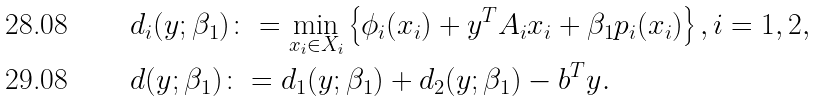Convert formula to latex. <formula><loc_0><loc_0><loc_500><loc_500>& d _ { i } ( y ; \beta _ { 1 } ) \colon = \min _ { x _ { i } \in X _ { i } } \left \{ \phi _ { i } ( x _ { i } ) + y ^ { T } A _ { i } x _ { i } + \beta _ { 1 } p _ { i } ( x _ { i } ) \right \} , i = 1 , 2 , \\ & d ( y ; \beta _ { 1 } ) \colon = d _ { 1 } ( y ; \beta _ { 1 } ) + d _ { 2 } ( y ; \beta _ { 1 } ) - b ^ { T } y .</formula> 